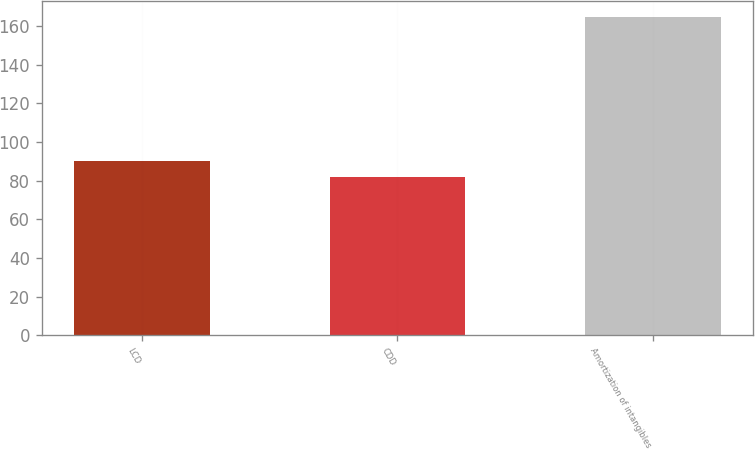Convert chart to OTSL. <chart><loc_0><loc_0><loc_500><loc_500><bar_chart><fcel>LCD<fcel>CDD<fcel>Amortization of intangibles<nl><fcel>90.34<fcel>82.1<fcel>164.5<nl></chart> 